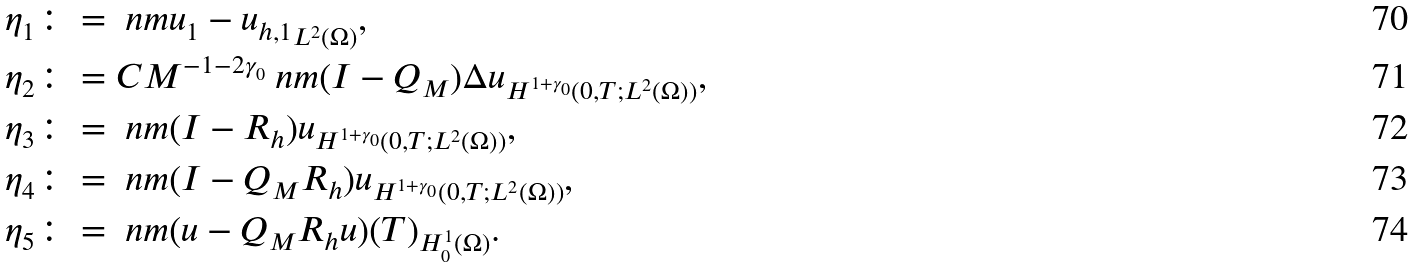<formula> <loc_0><loc_0><loc_500><loc_500>& \eta _ { 1 } \colon = \ n m { u _ { 1 } - u _ { h , 1 } } _ { L ^ { 2 } ( \Omega ) } , \\ & \eta _ { 2 } \colon = C M ^ { - 1 - 2 \gamma _ { 0 } } \ n m { ( I - Q _ { M } ) \Delta u } _ { H ^ { 1 + \gamma _ { 0 } } ( 0 , T ; L ^ { 2 } ( \Omega ) ) } , \\ & \eta _ { 3 } \colon = \ n m { ( I - R _ { h } ) u } _ { H ^ { 1 + \gamma _ { 0 } } ( 0 , T ; L ^ { 2 } ( \Omega ) ) } , \\ & \eta _ { 4 } \colon = \ n m { ( I - Q _ { M } R _ { h } ) u } _ { H ^ { 1 + \gamma _ { 0 } } ( 0 , T ; L ^ { 2 } ( \Omega ) ) } , \\ & \eta _ { 5 } \colon = \ n m { ( u - Q _ { M } R _ { h } u ) ( T ) } _ { H _ { 0 } ^ { 1 } ( \Omega ) } .</formula> 